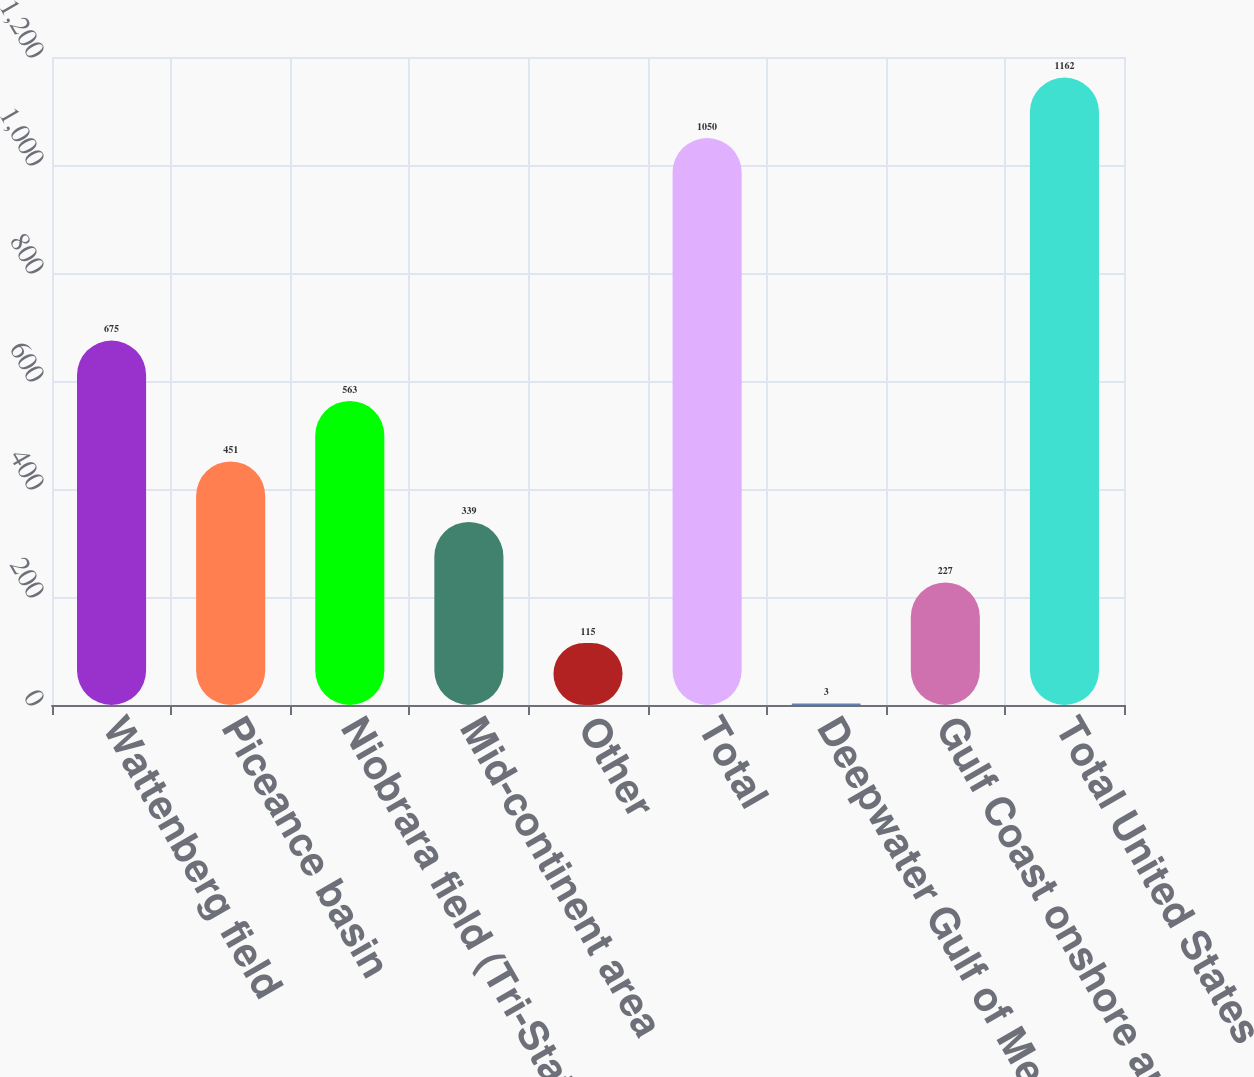<chart> <loc_0><loc_0><loc_500><loc_500><bar_chart><fcel>Wattenberg field<fcel>Piceance basin<fcel>Niobrara field (Tri-State<fcel>Mid-continent area<fcel>Other<fcel>Total<fcel>Deepwater Gulf of Mexico<fcel>Gulf Coast onshore and other<fcel>Total United States<nl><fcel>675<fcel>451<fcel>563<fcel>339<fcel>115<fcel>1050<fcel>3<fcel>227<fcel>1162<nl></chart> 